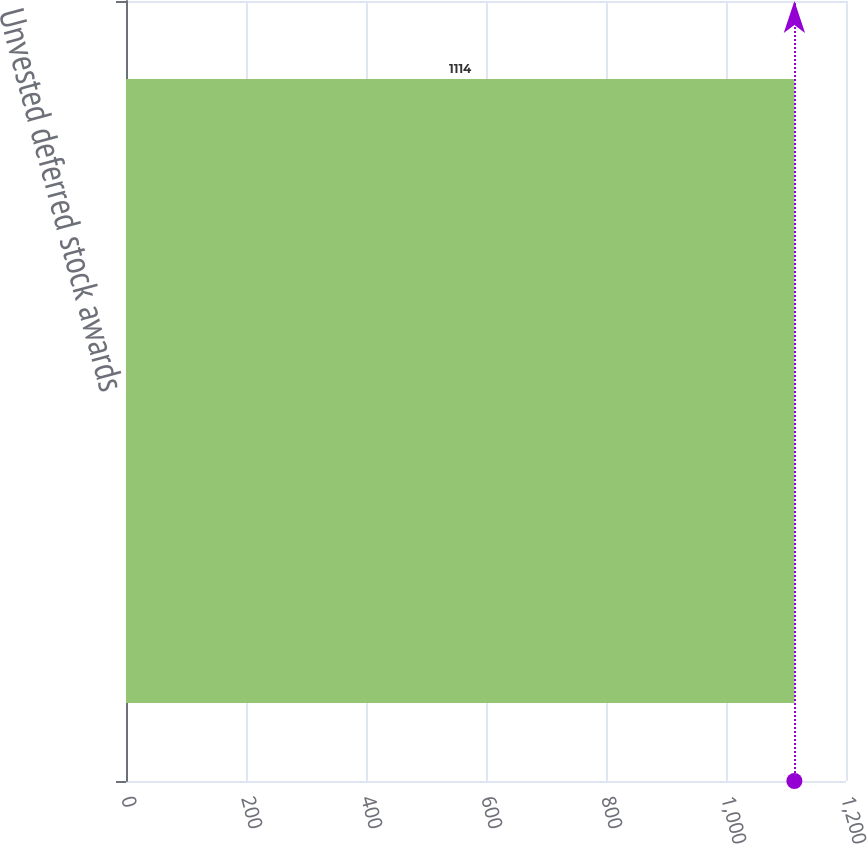<chart> <loc_0><loc_0><loc_500><loc_500><bar_chart><fcel>Unvested deferred stock awards<nl><fcel>1114<nl></chart> 